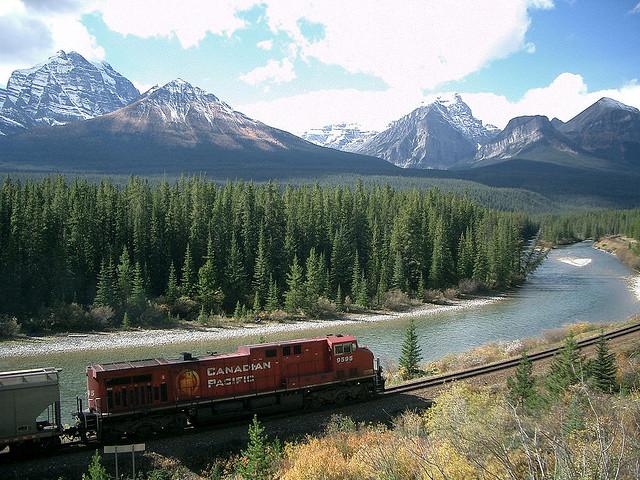Are there any animals visibly present in the picture?
Short answer required. No. What color is the front car of the train?
Answer briefly. Red. Is the train traveling through the desert?
Concise answer only. No. 